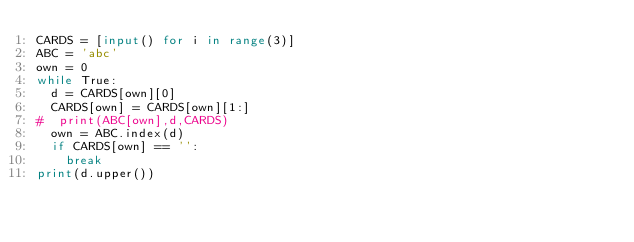<code> <loc_0><loc_0><loc_500><loc_500><_Python_>CARDS = [input() for i in range(3)]
ABC = 'abc'
own = 0
while True:
  d = CARDS[own][0]
  CARDS[own] = CARDS[own][1:]
#  print(ABC[own],d,CARDS)
  own = ABC.index(d)
  if CARDS[own] == '':
    break
print(d.upper())</code> 